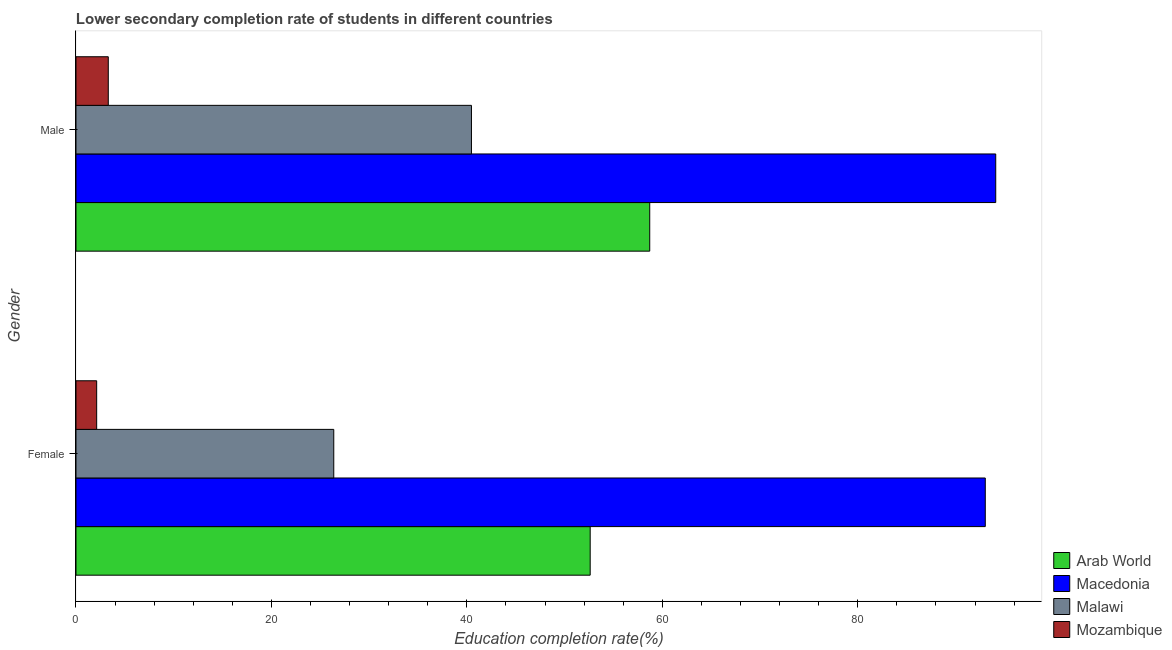How many groups of bars are there?
Offer a very short reply. 2. Are the number of bars per tick equal to the number of legend labels?
Provide a short and direct response. Yes. Are the number of bars on each tick of the Y-axis equal?
Offer a very short reply. Yes. How many bars are there on the 2nd tick from the bottom?
Make the answer very short. 4. What is the label of the 1st group of bars from the top?
Make the answer very short. Male. What is the education completion rate of female students in Malawi?
Keep it short and to the point. 26.38. Across all countries, what is the maximum education completion rate of female students?
Your answer should be compact. 93.05. Across all countries, what is the minimum education completion rate of female students?
Offer a very short reply. 2.12. In which country was the education completion rate of male students maximum?
Give a very brief answer. Macedonia. In which country was the education completion rate of male students minimum?
Offer a terse response. Mozambique. What is the total education completion rate of male students in the graph?
Keep it short and to the point. 196.61. What is the difference between the education completion rate of male students in Mozambique and that in Arab World?
Offer a very short reply. -55.41. What is the difference between the education completion rate of male students in Macedonia and the education completion rate of female students in Arab World?
Ensure brevity in your answer.  41.5. What is the average education completion rate of female students per country?
Your response must be concise. 43.54. What is the difference between the education completion rate of female students and education completion rate of male students in Arab World?
Provide a short and direct response. -6.09. In how many countries, is the education completion rate of male students greater than 88 %?
Your response must be concise. 1. What is the ratio of the education completion rate of female students in Malawi to that in Mozambique?
Keep it short and to the point. 12.47. In how many countries, is the education completion rate of female students greater than the average education completion rate of female students taken over all countries?
Ensure brevity in your answer.  2. What does the 4th bar from the top in Male represents?
Make the answer very short. Arab World. What does the 1st bar from the bottom in Male represents?
Give a very brief answer. Arab World. Are all the bars in the graph horizontal?
Give a very brief answer. Yes. How many countries are there in the graph?
Your answer should be very brief. 4. Are the values on the major ticks of X-axis written in scientific E-notation?
Your response must be concise. No. Does the graph contain grids?
Your answer should be compact. No. Where does the legend appear in the graph?
Offer a terse response. Bottom right. What is the title of the graph?
Make the answer very short. Lower secondary completion rate of students in different countries. What is the label or title of the X-axis?
Provide a short and direct response. Education completion rate(%). What is the Education completion rate(%) in Arab World in Female?
Give a very brief answer. 52.62. What is the Education completion rate(%) in Macedonia in Female?
Provide a succinct answer. 93.05. What is the Education completion rate(%) of Malawi in Female?
Provide a succinct answer. 26.38. What is the Education completion rate(%) in Mozambique in Female?
Give a very brief answer. 2.12. What is the Education completion rate(%) of Arab World in Male?
Keep it short and to the point. 58.71. What is the Education completion rate(%) in Macedonia in Male?
Give a very brief answer. 94.12. What is the Education completion rate(%) in Malawi in Male?
Your response must be concise. 40.47. What is the Education completion rate(%) in Mozambique in Male?
Ensure brevity in your answer.  3.31. Across all Gender, what is the maximum Education completion rate(%) in Arab World?
Ensure brevity in your answer.  58.71. Across all Gender, what is the maximum Education completion rate(%) in Macedonia?
Provide a short and direct response. 94.12. Across all Gender, what is the maximum Education completion rate(%) of Malawi?
Make the answer very short. 40.47. Across all Gender, what is the maximum Education completion rate(%) in Mozambique?
Provide a succinct answer. 3.31. Across all Gender, what is the minimum Education completion rate(%) in Arab World?
Provide a succinct answer. 52.62. Across all Gender, what is the minimum Education completion rate(%) of Macedonia?
Provide a short and direct response. 93.05. Across all Gender, what is the minimum Education completion rate(%) in Malawi?
Ensure brevity in your answer.  26.38. Across all Gender, what is the minimum Education completion rate(%) of Mozambique?
Make the answer very short. 2.12. What is the total Education completion rate(%) in Arab World in the graph?
Your answer should be compact. 111.33. What is the total Education completion rate(%) of Macedonia in the graph?
Offer a very short reply. 187.17. What is the total Education completion rate(%) of Malawi in the graph?
Your answer should be very brief. 66.85. What is the total Education completion rate(%) in Mozambique in the graph?
Your answer should be very brief. 5.42. What is the difference between the Education completion rate(%) of Arab World in Female and that in Male?
Make the answer very short. -6.09. What is the difference between the Education completion rate(%) of Macedonia in Female and that in Male?
Your answer should be compact. -1.07. What is the difference between the Education completion rate(%) of Malawi in Female and that in Male?
Provide a succinct answer. -14.09. What is the difference between the Education completion rate(%) of Mozambique in Female and that in Male?
Your answer should be compact. -1.19. What is the difference between the Education completion rate(%) of Arab World in Female and the Education completion rate(%) of Macedonia in Male?
Make the answer very short. -41.5. What is the difference between the Education completion rate(%) of Arab World in Female and the Education completion rate(%) of Malawi in Male?
Ensure brevity in your answer.  12.15. What is the difference between the Education completion rate(%) of Arab World in Female and the Education completion rate(%) of Mozambique in Male?
Your response must be concise. 49.31. What is the difference between the Education completion rate(%) in Macedonia in Female and the Education completion rate(%) in Malawi in Male?
Ensure brevity in your answer.  52.58. What is the difference between the Education completion rate(%) in Macedonia in Female and the Education completion rate(%) in Mozambique in Male?
Give a very brief answer. 89.75. What is the difference between the Education completion rate(%) of Malawi in Female and the Education completion rate(%) of Mozambique in Male?
Make the answer very short. 23.07. What is the average Education completion rate(%) in Arab World per Gender?
Give a very brief answer. 55.67. What is the average Education completion rate(%) in Macedonia per Gender?
Ensure brevity in your answer.  93.58. What is the average Education completion rate(%) in Malawi per Gender?
Your response must be concise. 33.42. What is the average Education completion rate(%) in Mozambique per Gender?
Offer a terse response. 2.71. What is the difference between the Education completion rate(%) of Arab World and Education completion rate(%) of Macedonia in Female?
Keep it short and to the point. -40.43. What is the difference between the Education completion rate(%) of Arab World and Education completion rate(%) of Malawi in Female?
Ensure brevity in your answer.  26.24. What is the difference between the Education completion rate(%) of Arab World and Education completion rate(%) of Mozambique in Female?
Offer a terse response. 50.5. What is the difference between the Education completion rate(%) of Macedonia and Education completion rate(%) of Malawi in Female?
Offer a very short reply. 66.67. What is the difference between the Education completion rate(%) in Macedonia and Education completion rate(%) in Mozambique in Female?
Offer a terse response. 90.93. What is the difference between the Education completion rate(%) in Malawi and Education completion rate(%) in Mozambique in Female?
Offer a very short reply. 24.26. What is the difference between the Education completion rate(%) in Arab World and Education completion rate(%) in Macedonia in Male?
Provide a succinct answer. -35.41. What is the difference between the Education completion rate(%) in Arab World and Education completion rate(%) in Malawi in Male?
Offer a very short reply. 18.24. What is the difference between the Education completion rate(%) of Arab World and Education completion rate(%) of Mozambique in Male?
Offer a terse response. 55.41. What is the difference between the Education completion rate(%) in Macedonia and Education completion rate(%) in Malawi in Male?
Keep it short and to the point. 53.65. What is the difference between the Education completion rate(%) in Macedonia and Education completion rate(%) in Mozambique in Male?
Offer a terse response. 90.81. What is the difference between the Education completion rate(%) in Malawi and Education completion rate(%) in Mozambique in Male?
Provide a succinct answer. 37.16. What is the ratio of the Education completion rate(%) of Arab World in Female to that in Male?
Ensure brevity in your answer.  0.9. What is the ratio of the Education completion rate(%) of Macedonia in Female to that in Male?
Keep it short and to the point. 0.99. What is the ratio of the Education completion rate(%) of Malawi in Female to that in Male?
Ensure brevity in your answer.  0.65. What is the ratio of the Education completion rate(%) in Mozambique in Female to that in Male?
Your answer should be compact. 0.64. What is the difference between the highest and the second highest Education completion rate(%) in Arab World?
Make the answer very short. 6.09. What is the difference between the highest and the second highest Education completion rate(%) in Macedonia?
Keep it short and to the point. 1.07. What is the difference between the highest and the second highest Education completion rate(%) of Malawi?
Your response must be concise. 14.09. What is the difference between the highest and the second highest Education completion rate(%) of Mozambique?
Provide a succinct answer. 1.19. What is the difference between the highest and the lowest Education completion rate(%) in Arab World?
Your answer should be compact. 6.09. What is the difference between the highest and the lowest Education completion rate(%) of Macedonia?
Offer a very short reply. 1.07. What is the difference between the highest and the lowest Education completion rate(%) of Malawi?
Give a very brief answer. 14.09. What is the difference between the highest and the lowest Education completion rate(%) in Mozambique?
Ensure brevity in your answer.  1.19. 